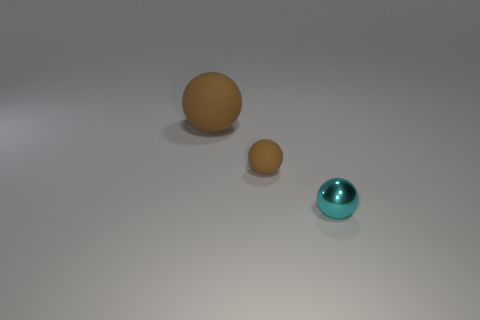Is there anything else that has the same material as the small cyan ball?
Provide a short and direct response. No. Is there a small brown matte object behind the tiny ball behind the metallic ball?
Provide a short and direct response. No. What is the color of the matte thing in front of the sphere that is on the left side of the rubber sphere that is in front of the big object?
Ensure brevity in your answer.  Brown. What color is the object that is the same size as the metal sphere?
Your answer should be compact. Brown. There is a large sphere; is it the same color as the small object that is to the left of the shiny ball?
Provide a short and direct response. Yes. What material is the sphere that is in front of the brown ball in front of the large ball made of?
Keep it short and to the point. Metal. What number of balls are both to the right of the large brown rubber ball and on the left side of the tiny cyan metallic object?
Offer a terse response. 1. What number of other things are there of the same size as the metal ball?
Provide a succinct answer. 1. There is a cyan shiny thing; are there any big brown matte balls left of it?
Ensure brevity in your answer.  Yes. What is the color of the other big thing that is the same shape as the cyan metal object?
Your answer should be compact. Brown. 